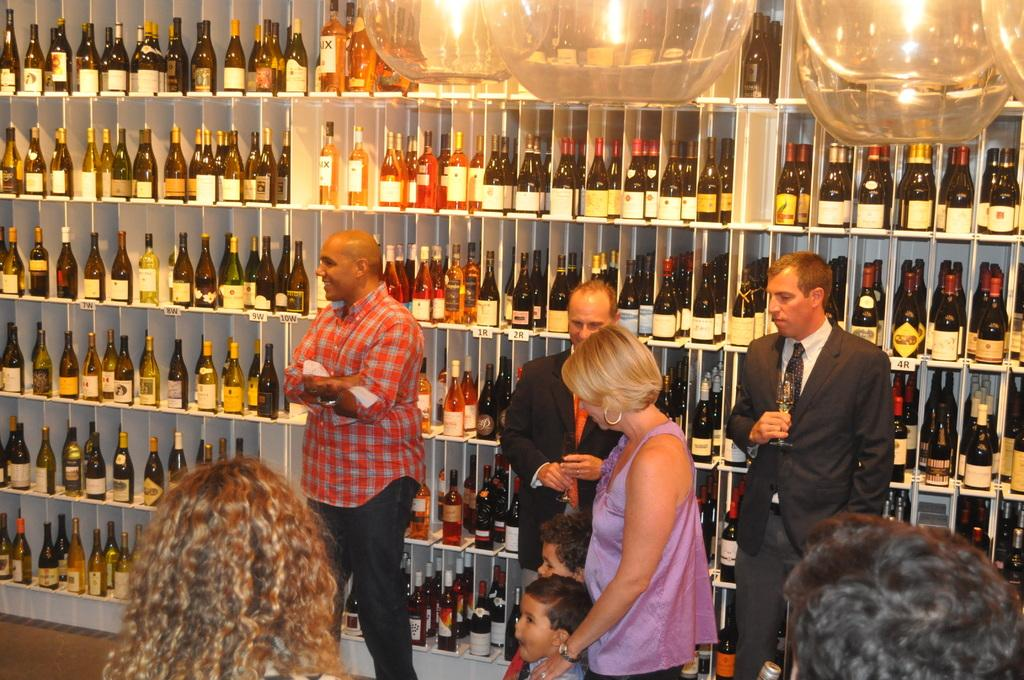What is the main subject of the image? The main subject of the image is persons standing. What objects can be seen besides the persons in the image? There are bottles visible in the image. What type of lighting is present in the image? There are lights on the top in the image. How many pizzas are being served by the persons in the image? There is no indication of pizzas being served in the image. What type of plantation can be seen in the background of the image? There is no plantation present in the image. What magical powers do the lights on the top possess in the image? The lights on the top do not possess any magical powers; they are simply a source of lighting. 